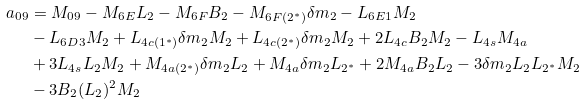Convert formula to latex. <formula><loc_0><loc_0><loc_500><loc_500>a _ { 0 9 } & = M _ { 0 9 } - M _ { 6 E } L _ { 2 } - M _ { 6 F } B _ { 2 } - M _ { 6 F ( 2 ^ { \ast } ) } \delta m _ { 2 } - L _ { 6 E 1 } M _ { 2 } \\ & - L _ { 6 D 3 } M _ { 2 } + L _ { 4 c ( 1 ^ { \ast } ) } \delta m _ { 2 } M _ { 2 } + L _ { 4 c ( 2 ^ { \ast } ) } \delta m _ { 2 } M _ { 2 } + 2 L _ { 4 c } B _ { 2 } M _ { 2 } - L _ { 4 s } M _ { 4 a } \\ & + 3 L _ { 4 s } L _ { 2 } M _ { 2 } + M _ { 4 a ( 2 ^ { \ast } ) } \delta m _ { 2 } L _ { 2 } + M _ { 4 a } \delta m _ { 2 } L _ { 2 ^ { \ast } } + 2 M _ { 4 a } B _ { 2 } L _ { 2 } - 3 \delta m _ { 2 } L _ { 2 } L _ { 2 ^ { \ast } } M _ { 2 } \\ & - 3 B _ { 2 } ( L _ { 2 } ) ^ { 2 } M _ { 2 }</formula> 